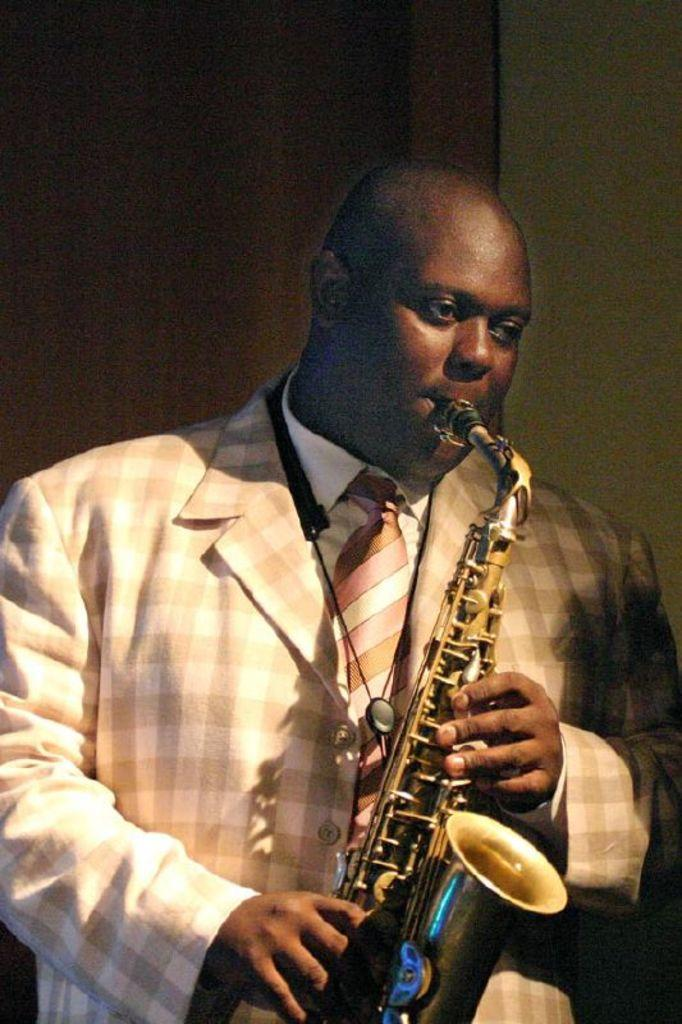Who is the main subject in the image? There is a man in the image. What is the man wearing? The man is wearing a suit. What is the man doing in the image? The man is playing a musical instrument. What can be seen in the background of the image? There is a wooden plank and a wall in the background of the image. How far is the man's loss from the starting point in the image? There is no indication of loss or a starting point in the image; it simply shows a man playing a musical instrument. 